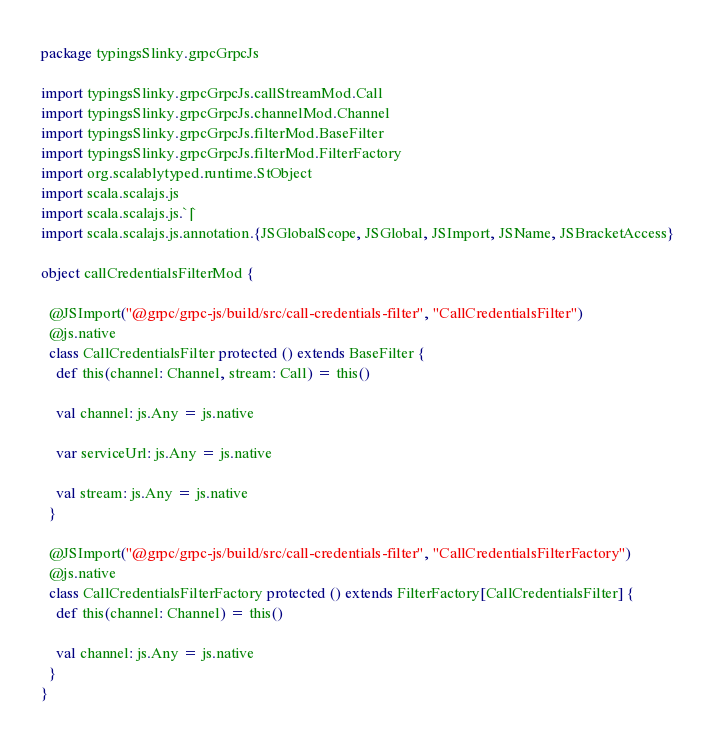<code> <loc_0><loc_0><loc_500><loc_500><_Scala_>package typingsSlinky.grpcGrpcJs

import typingsSlinky.grpcGrpcJs.callStreamMod.Call
import typingsSlinky.grpcGrpcJs.channelMod.Channel
import typingsSlinky.grpcGrpcJs.filterMod.BaseFilter
import typingsSlinky.grpcGrpcJs.filterMod.FilterFactory
import org.scalablytyped.runtime.StObject
import scala.scalajs.js
import scala.scalajs.js.`|`
import scala.scalajs.js.annotation.{JSGlobalScope, JSGlobal, JSImport, JSName, JSBracketAccess}

object callCredentialsFilterMod {
  
  @JSImport("@grpc/grpc-js/build/src/call-credentials-filter", "CallCredentialsFilter")
  @js.native
  class CallCredentialsFilter protected () extends BaseFilter {
    def this(channel: Channel, stream: Call) = this()
    
    val channel: js.Any = js.native
    
    var serviceUrl: js.Any = js.native
    
    val stream: js.Any = js.native
  }
  
  @JSImport("@grpc/grpc-js/build/src/call-credentials-filter", "CallCredentialsFilterFactory")
  @js.native
  class CallCredentialsFilterFactory protected () extends FilterFactory[CallCredentialsFilter] {
    def this(channel: Channel) = this()
    
    val channel: js.Any = js.native
  }
}
</code> 